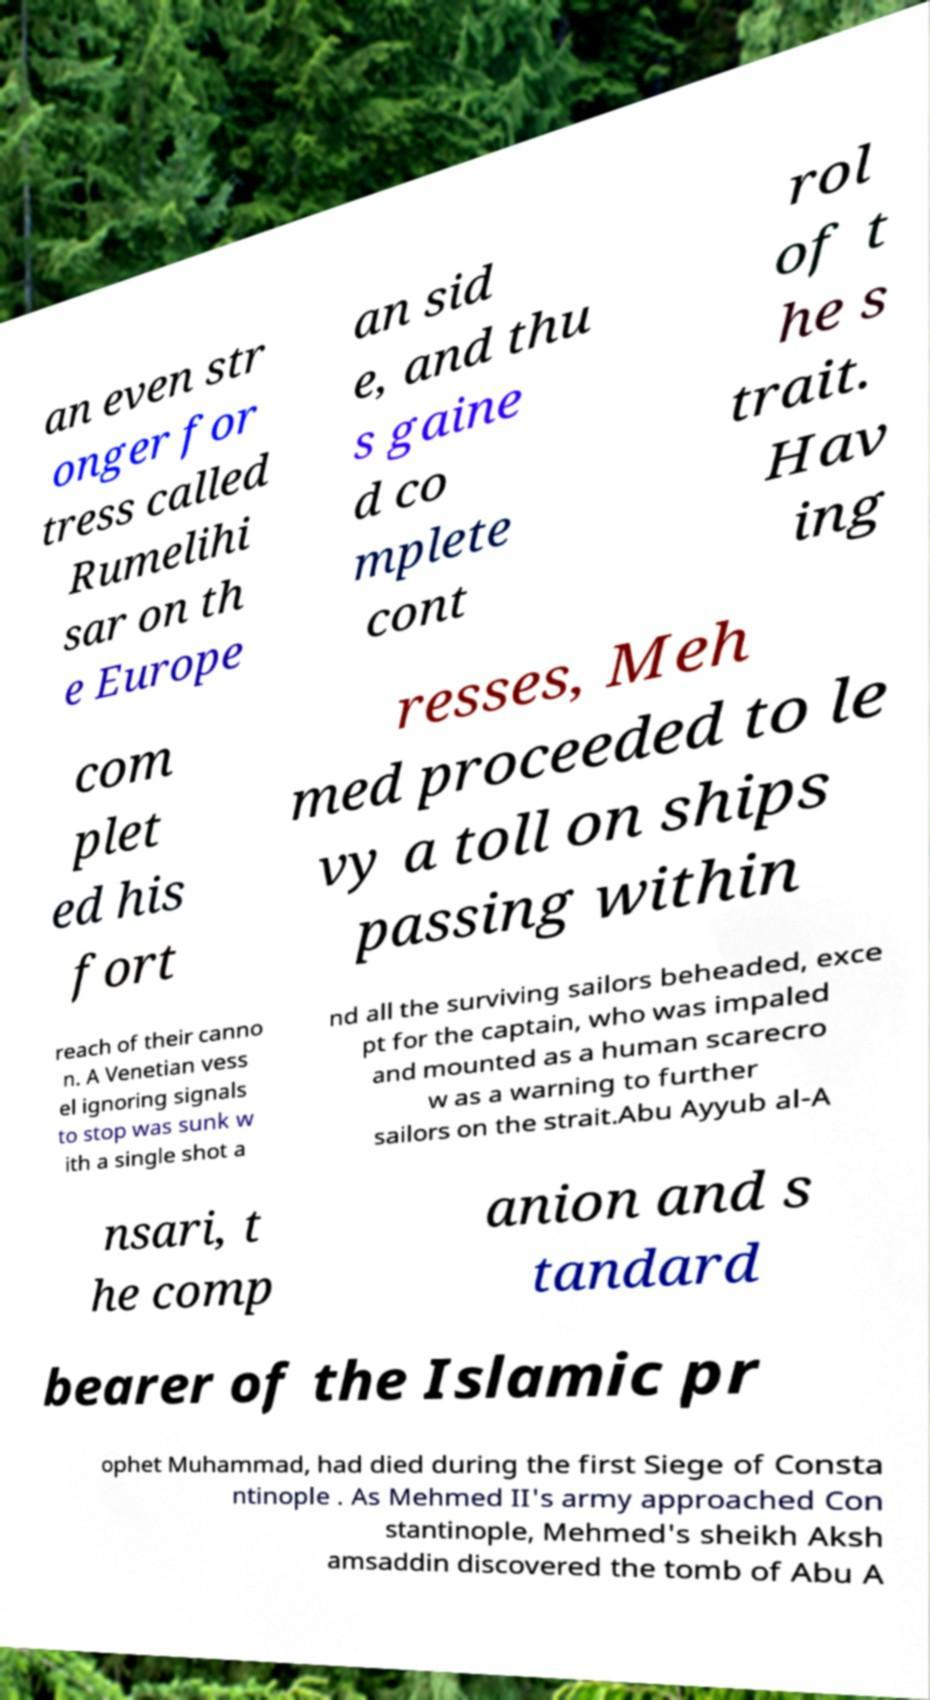For documentation purposes, I need the text within this image transcribed. Could you provide that? an even str onger for tress called Rumelihi sar on th e Europe an sid e, and thu s gaine d co mplete cont rol of t he s trait. Hav ing com plet ed his fort resses, Meh med proceeded to le vy a toll on ships passing within reach of their canno n. A Venetian vess el ignoring signals to stop was sunk w ith a single shot a nd all the surviving sailors beheaded, exce pt for the captain, who was impaled and mounted as a human scarecro w as a warning to further sailors on the strait.Abu Ayyub al-A nsari, t he comp anion and s tandard bearer of the Islamic pr ophet Muhammad, had died during the first Siege of Consta ntinople . As Mehmed II's army approached Con stantinople, Mehmed's sheikh Aksh amsaddin discovered the tomb of Abu A 